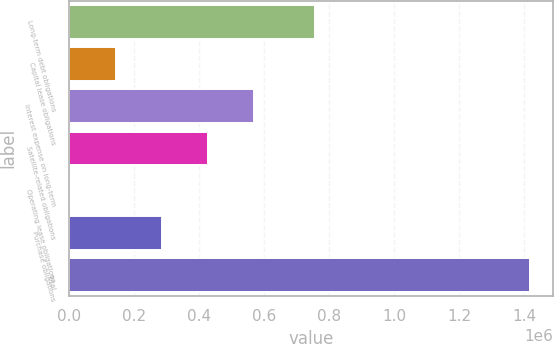Convert chart. <chart><loc_0><loc_0><loc_500><loc_500><bar_chart><fcel>Long-term debt obligations<fcel>Capital lease obligations<fcel>Interest expense on long-term<fcel>Satellite-related obligations<fcel>Operating lease obligations<fcel>Purchase obligations<fcel>Total<nl><fcel>756160<fcel>144598<fcel>569163<fcel>427641<fcel>3077<fcel>286120<fcel>1.41829e+06<nl></chart> 